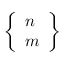Convert formula to latex. <formula><loc_0><loc_0><loc_500><loc_500>\left \{ { \begin{array} { l } { n } \\ { m } \end{array} } \right \}</formula> 